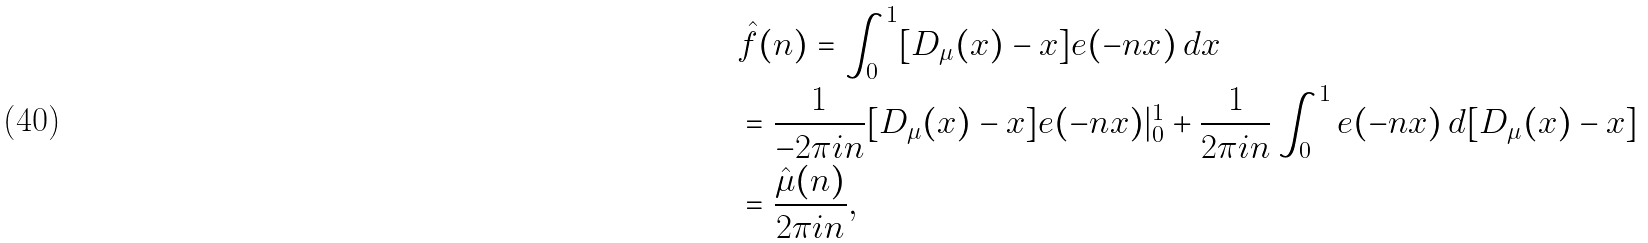<formula> <loc_0><loc_0><loc_500><loc_500>& \hat { f } ( n ) = \int _ { 0 } ^ { 1 } [ D _ { \mu } ( x ) - x ] e ( - n x ) \, d x \\ & = \frac { 1 } { - 2 \pi i n } [ D _ { \mu } ( x ) - x ] e ( - n x ) | _ { 0 } ^ { 1 } + \frac { 1 } { 2 \pi i n } \int _ { 0 } ^ { 1 } e ( - n x ) \, d [ D _ { \mu } ( x ) - x ] \\ & = \frac { \hat { \mu } ( n ) } { 2 \pi i n } ,</formula> 